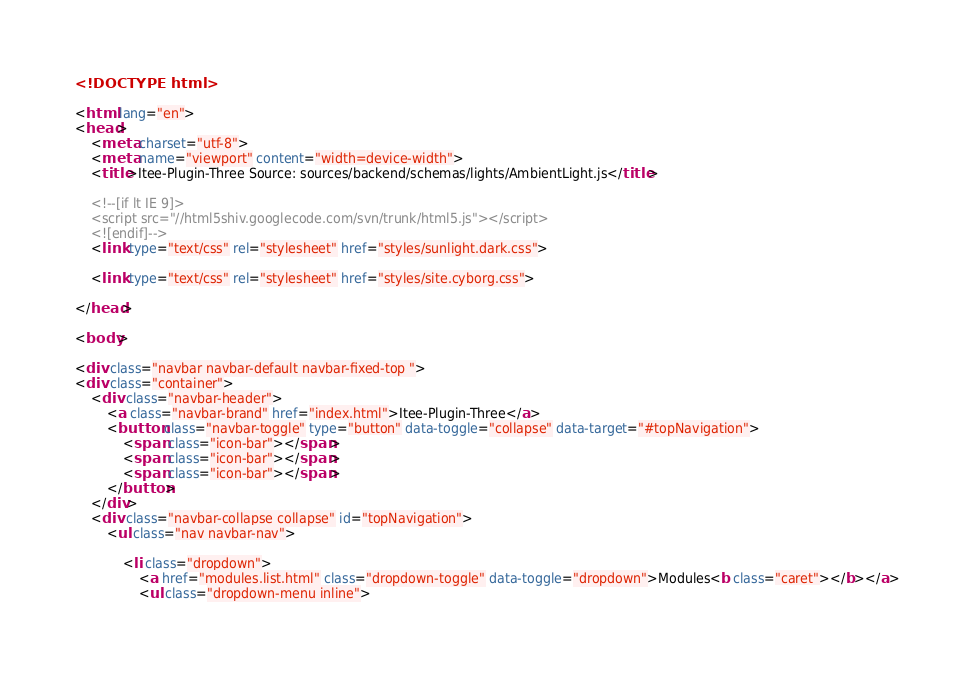Convert code to text. <code><loc_0><loc_0><loc_500><loc_500><_HTML_><!DOCTYPE html>

<html lang="en">
<head>
	<meta charset="utf-8">
	<meta name="viewport" content="width=device-width">
	<title>Itee-Plugin-Three Source: sources/backend/schemas/lights/AmbientLight.js</title>

	<!--[if lt IE 9]>
	<script src="//html5shiv.googlecode.com/svn/trunk/html5.js"></script>
	<![endif]-->
	<link type="text/css" rel="stylesheet" href="styles/sunlight.dark.css">

	<link type="text/css" rel="stylesheet" href="styles/site.cyborg.css">

</head>

<body>

<div class="navbar navbar-default navbar-fixed-top ">
<div class="container">
	<div class="navbar-header">
		<a class="navbar-brand" href="index.html">Itee-Plugin-Three</a>
		<button class="navbar-toggle" type="button" data-toggle="collapse" data-target="#topNavigation">
			<span class="icon-bar"></span>
			<span class="icon-bar"></span>
			<span class="icon-bar"></span>
        </button>
	</div>
	<div class="navbar-collapse collapse" id="topNavigation">
		<ul class="nav navbar-nav">
			
			<li class="dropdown">
				<a href="modules.list.html" class="dropdown-toggle" data-toggle="dropdown">Modules<b class="caret"></b></a>
				<ul class="dropdown-menu inline"></code> 